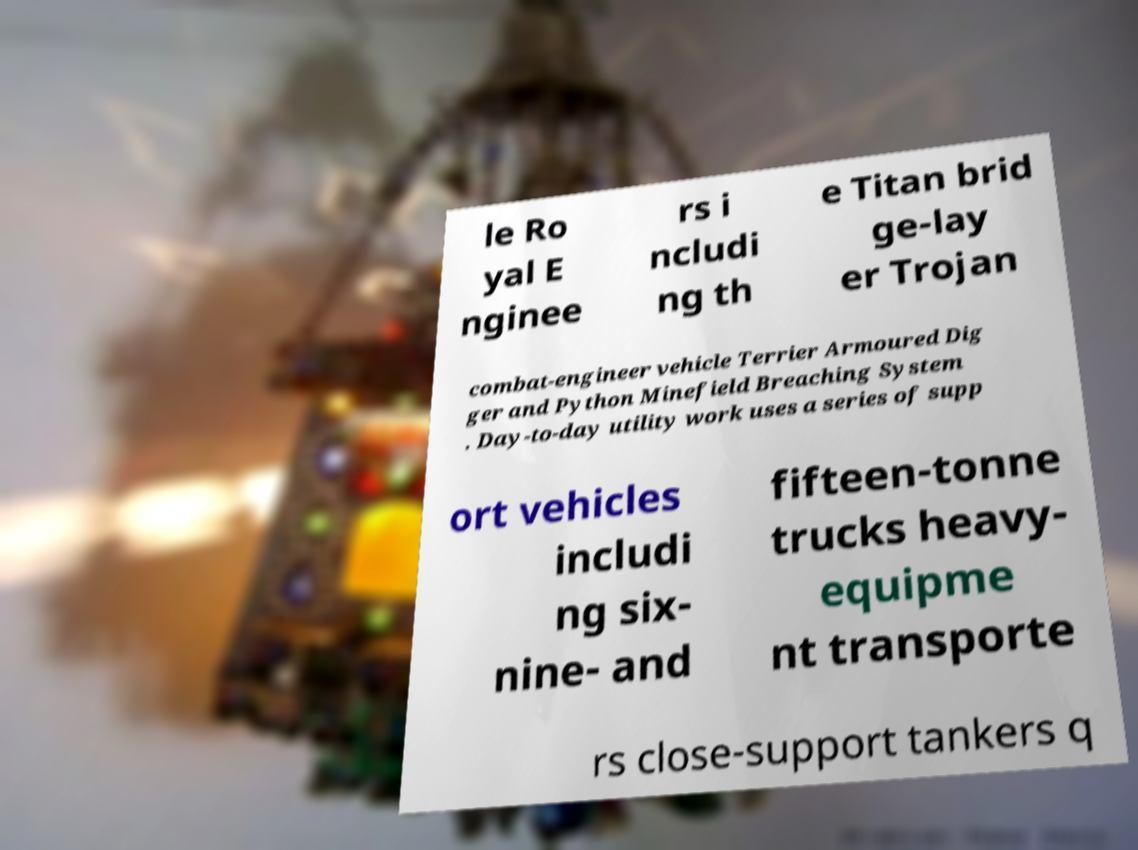There's text embedded in this image that I need extracted. Can you transcribe it verbatim? le Ro yal E nginee rs i ncludi ng th e Titan brid ge-lay er Trojan combat-engineer vehicle Terrier Armoured Dig ger and Python Minefield Breaching System . Day-to-day utility work uses a series of supp ort vehicles includi ng six- nine- and fifteen-tonne trucks heavy- equipme nt transporte rs close-support tankers q 